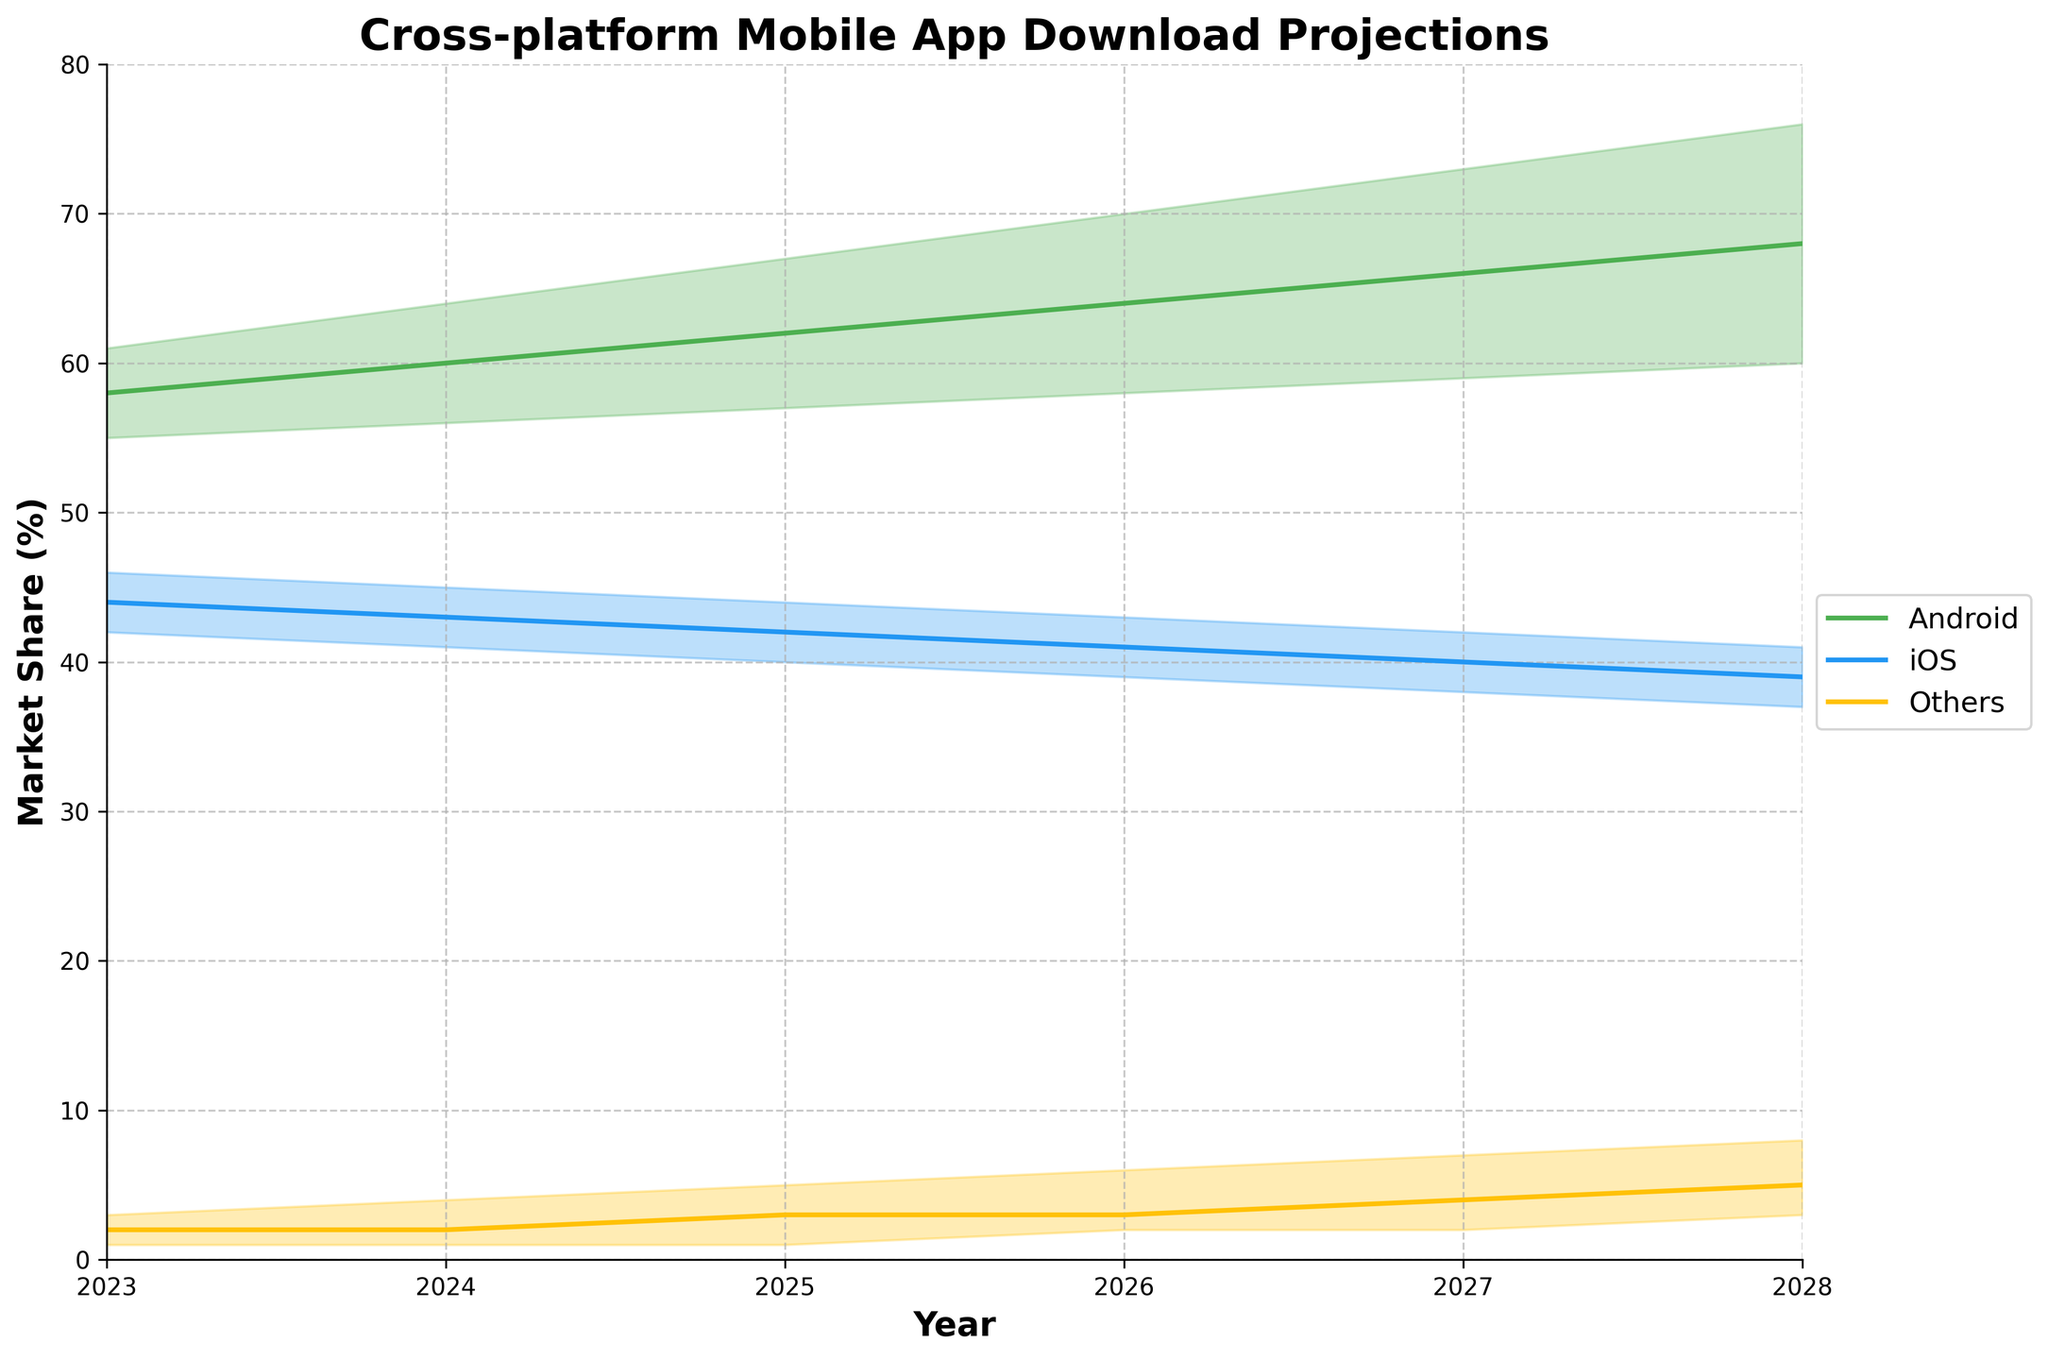How many years are covered in this figure? The x-axis starts at 2023 and ends at 2028, inclusive. Counting the number of tick marks or years in this range gives us 6 years.
Answer: 6 What is the market share range for Android in 2026? The region filled for Android in 2026 spans from the lower bound to the upper bound shown on the y-axis. For 2026, the Android market share ranges from 58% to 70%.
Answer: 58% to 70% Which operating system is projected to have the smallest market share in 2028? By looking at the midlines for each platform, we check the values at 2028. "Others" has the smallest value at around 4%.
Answer: Others In 2024, which operating system has the largest midline market share? By observing the midpoints for Android, iOS, and Others in 2024, Android's 60% is higher than iOS's 43% and Others' 2%.
Answer: Android What is the average projected high market share for iOS from 2025 to 2027? For the years 2025, 2026, and 2027, the high projections for iOS are 44%, 43%, and 42%. The average is calculated as (44 + 43 + 42) / 3 = 43%.
Answer: 43% Is Android's high projection in 2027 greater than iOS's high projection in 2025? Comparing the visual information: Android's high projection for 2027 is 73%, and iOS's high projection for 2025 is 44%. 73% is greater than 44%.
Answer: Yes How does the market share range for "Others" change from 2023 to 2028? In 2023, "Others" ranges from 1% to 3%. By 2028, "Others" ranges from 3% to 8%, indicating an increase in both lower and upper bounds.
Answer: Increases What trend in market share can be observed for iOS from 2023 to 2028? By following the midline for iOS from 2023 to 2028, the trend is a gradual decrease in market share from 44% to 39%.
Answer: Decreasing Does any operating system show a continuous increase in the midline projection from 2023 to 2028? Android's midline projection increases each year from 58% in 2023 to 68% in 2028.
Answer: Yes, Android What is the difference between low and high projections for "Others" in 2025? For 2025, the low projection for "Others" is 1% and the high projection is 5%. The difference is 5% - 1% = 4%.
Answer: 4% 